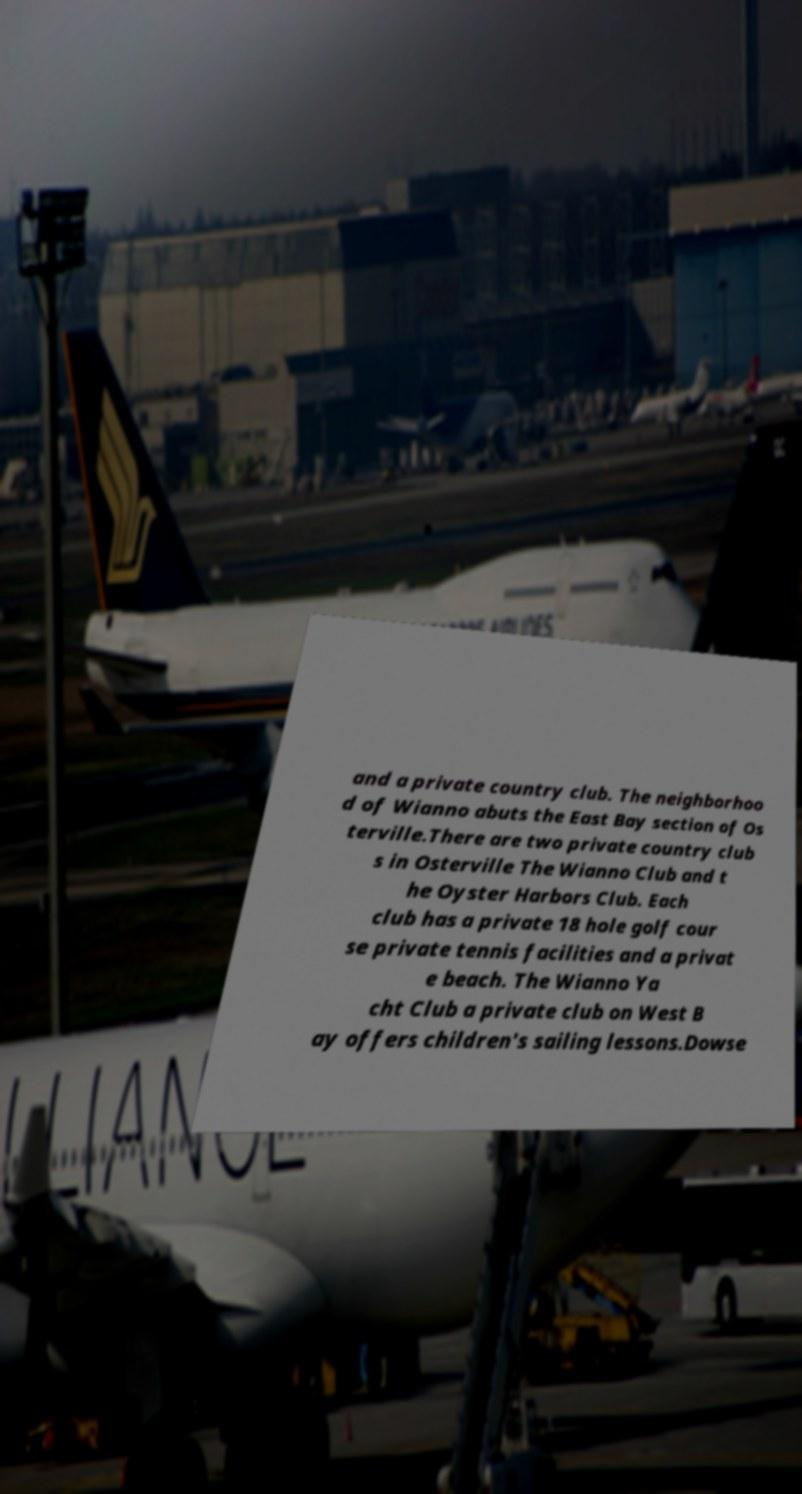Could you extract and type out the text from this image? and a private country club. The neighborhoo d of Wianno abuts the East Bay section of Os terville.There are two private country club s in Osterville The Wianno Club and t he Oyster Harbors Club. Each club has a private 18 hole golf cour se private tennis facilities and a privat e beach. The Wianno Ya cht Club a private club on West B ay offers children's sailing lessons.Dowse 